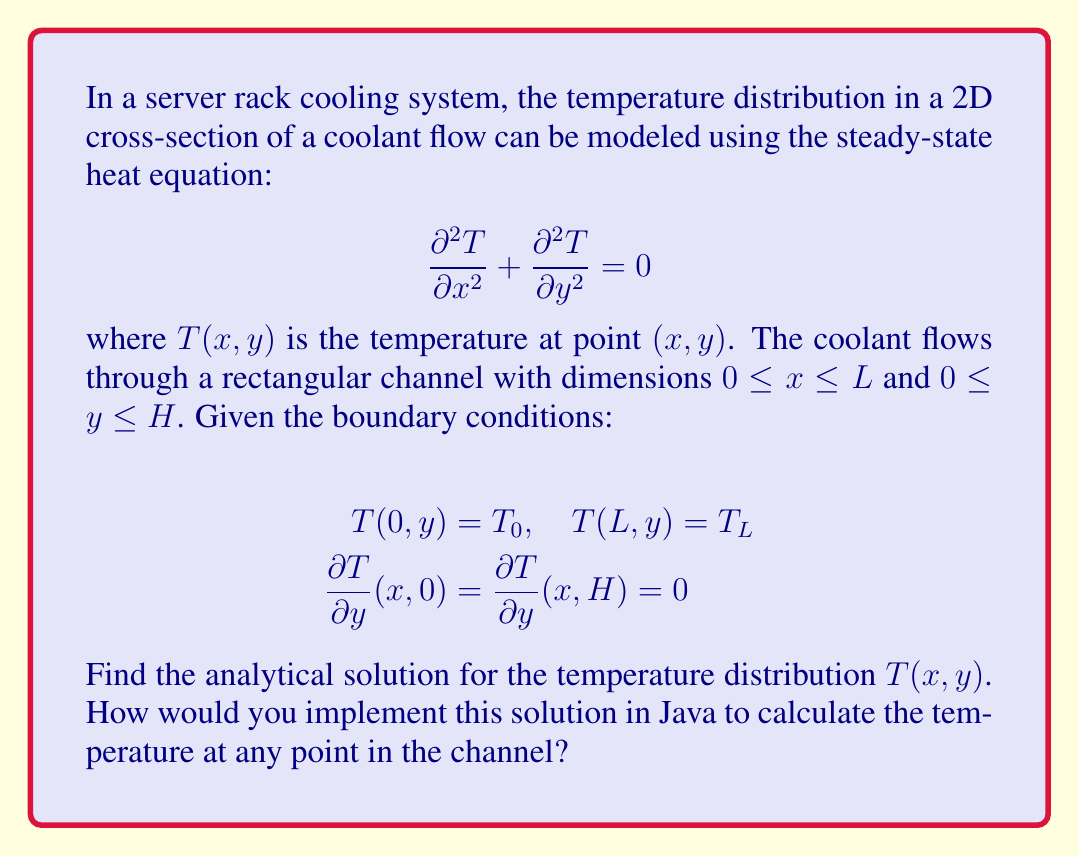Help me with this question. To solve this partial differential equation (PDE) problem, we'll use the separation of variables method. This approach is suitable for implementing in Java, as it results in a series solution that can be easily computed.

1. Assume the solution has the form $T(x,y) = X(x)Y(y)$.

2. Substituting this into the PDE:
   $$Y\frac{d^2X}{dx^2} + X\frac{d^2Y}{dy^2} = 0$$

3. Dividing by $XY$:
   $$\frac{1}{X}\frac{d^2X}{dx^2} = -\frac{1}{Y}\frac{d^2Y}{dy^2} = -\lambda^2$$

4. This gives us two ODEs:
   $$\frac{d^2X}{dx^2} + \lambda^2X = 0$$
   $$\frac{d^2Y}{dy^2} - \lambda^2Y = 0$$

5. The general solutions are:
   $$X(x) = A\cos(\lambda x) + B\sin(\lambda x)$$
   $$Y(y) = C\cosh(\lambda y) + D\sinh(\lambda y)$$

6. Applying the boundary conditions for $y$:
   $$\frac{dY}{dy}(0) = \frac{dY}{dy}(H) = 0$$
   This results in $D = 0$ and $\lambda_n = \frac{n\pi}{H}$ for $n = 0, 1, 2, ...$

7. The solution then takes the form:
   $$T(x,y) = \sum_{n=0}^{\infty} [A_n\cos(\frac{n\pi x}{H}) + B_n\sin(\frac{n\pi x}{H})]\cos(\frac{n\pi y}{H})$$

8. Applying the boundary conditions for $x$:
   $$T(0,y) = T_0, \quad T(L,y) = T_L$$
   We get:
   $$A_0 = T_0, \quad A_n\cos(\frac{n\pi L}{H}) + B_n\sin(\frac{n\pi L}{H}) = 0$$
   $$B_n = \frac{2(T_L - T_0)}{n\pi}\sin(\frac{n\pi L}{H})$$

9. The final solution is:
   $$T(x,y) = T_0 + (T_L - T_0)\frac{x}{L} + \sum_{n=1}^{\infty} \frac{2(T_L - T_0)}{n\pi}\sin(\frac{n\pi L}{H})\sin(\frac{n\pi x}{H})\cos(\frac{n\pi y}{H})$$

To implement this in Java, you would create a method that takes as input the coordinates $(x,y)$, the channel dimensions $L$ and $H$, the boundary temperatures $T_0$ and $T_L$, and the number of terms to use in the series approximation. The method would then compute and return the temperature at the given point.
Answer: The analytical solution for the temperature distribution is:

$$T(x,y) = T_0 + (T_L - T_0)\frac{x}{L} + \sum_{n=1}^{\infty} \frac{2(T_L - T_0)}{n\pi}\sin(\frac{n\pi L}{H})\sin(\frac{n\pi x}{H})\cos(\frac{n\pi y}{H})$$

To implement this in Java, you would create a method like:

```java
public double calculateTemperature(double x, double y, double L, double H, double T0, double TL, int numTerms) {
    double T = T0 + (TL - T0) * x / L;
    for (int n = 1; n <= numTerms; n++) {
        T += 2 * (TL - T0) / (n * Math.PI) * 
             Math.sin(n * Math.PI * L / H) * 
             Math.sin(n * Math.PI * x / H) * 
             Math.cos(n * Math.PI * y / H);
    }
    return T;
}
```

This method calculates the temperature at any point (x,y) in the channel, allowing for efficient analysis of the cooling system's performance. 